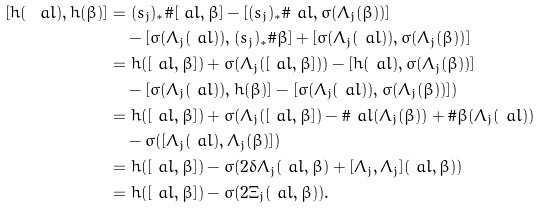<formula> <loc_0><loc_0><loc_500><loc_500>[ h ( \ a l ) , h ( \beta ) ] & = ( s _ { j } ) _ { * } \# [ \ a l , \beta ] - [ ( s _ { j } ) _ { * } \# \ a l , \sigma ( \Lambda _ { j } ( \beta ) ) ] \\ & \quad - [ \sigma ( \Lambda _ { j } ( \ a l ) ) , ( s _ { j } ) _ { * } \# \beta ] + [ \sigma ( \Lambda _ { j } ( \ a l ) ) , \sigma ( \Lambda _ { j } ( \beta ) ) ] \\ & = h ( [ \ a l , \beta ] ) + \sigma ( \Lambda _ { j } ( [ \ a l , \beta ] ) ) - [ h ( \ a l ) , \sigma ( \Lambda _ { j } ( \beta ) ) ] \\ & \quad - [ \sigma ( \Lambda _ { j } ( \ a l ) ) , h ( \beta ) ] - [ \sigma ( \Lambda _ { j } ( \ a l ) ) , \sigma ( \Lambda _ { j } ( \beta ) ) ] ) \\ & = h ( [ \ a l , \beta ] ) + \sigma ( \Lambda _ { j } ( [ \ a l , \beta ] ) - \# \ a l ( \Lambda _ { j } ( \beta ) ) + \# \beta ( \Lambda _ { j } ( \ a l ) ) \\ & \quad - \sigma ( [ \Lambda _ { j } ( \ a l ) , \Lambda _ { j } ( \beta ) ] ) \\ & = h ( [ \ a l , \beta ] ) - \sigma ( 2 \delta \Lambda _ { j } ( \ a l , \beta ) + [ \Lambda _ { j } , \Lambda _ { j } ] ( \ a l , \beta ) ) \\ & = h ( [ \ a l , \beta ] ) - \sigma ( 2 \Xi _ { j } ( \ a l , \beta ) ) .</formula> 